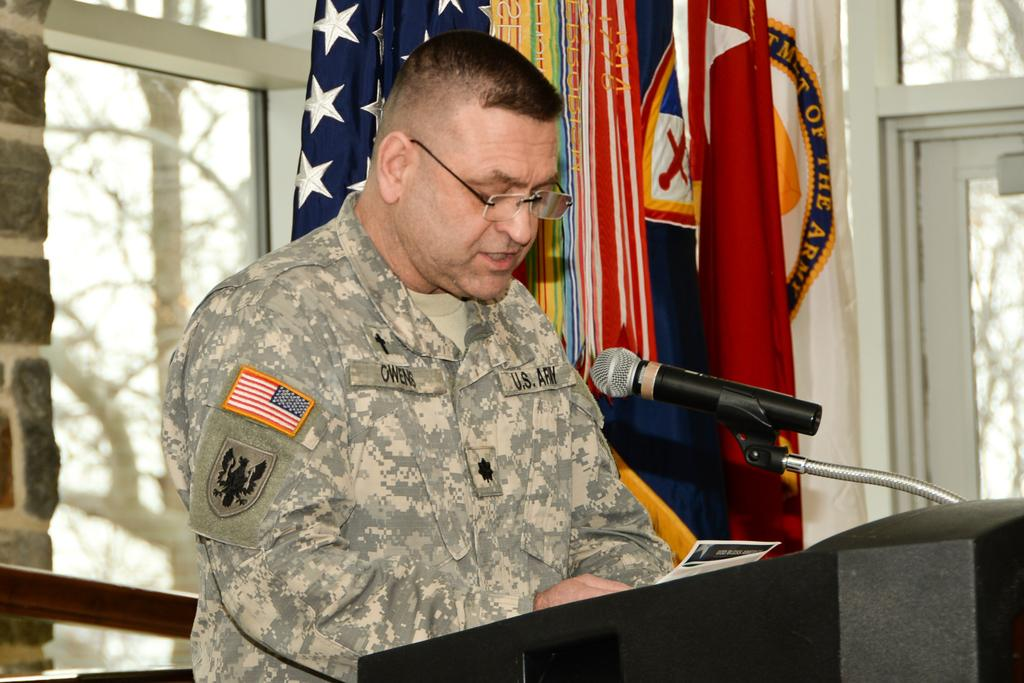What is the person in the image doing? There is a person standing at a desk in the image. What object is on the desk in the image? There is a microphone (mic) on the desk. What can be seen in the background of the image? There are flags, windows, trees, and a wall visible in the background of the image. What type of spring is visible in the image? There is no spring present in the image. Can you describe the patch on the person's clothing in the image? There is no patch mentioned or visible on the person's clothing in the image. 